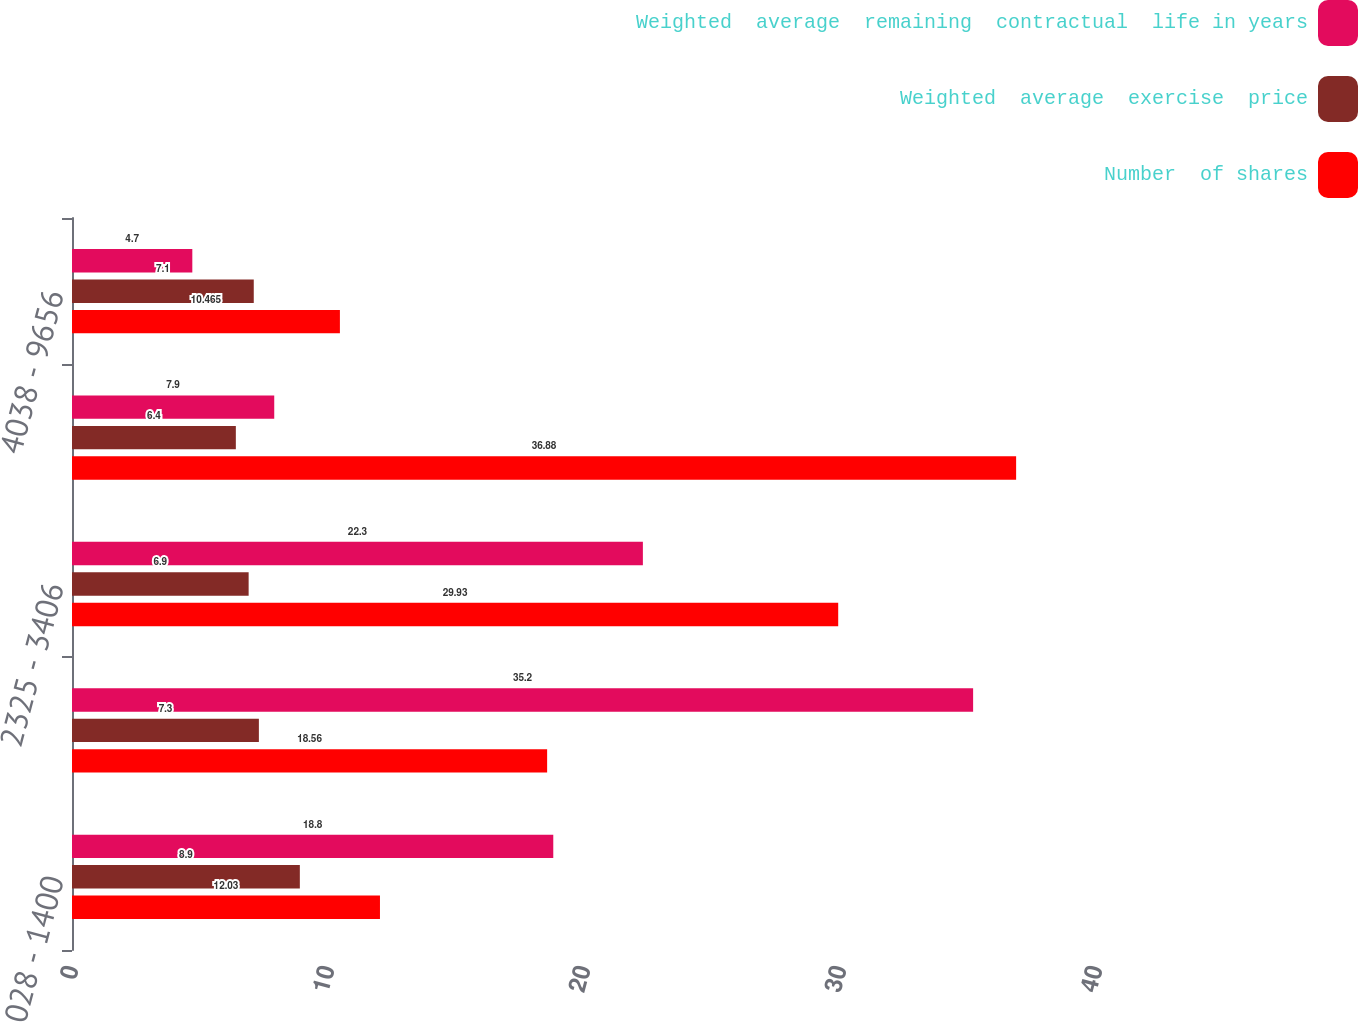Convert chart. <chart><loc_0><loc_0><loc_500><loc_500><stacked_bar_chart><ecel><fcel>028 - 1400<fcel>1402 - 2283<fcel>2325 - 3406<fcel>3409 - 4006<fcel>4038 - 9656<nl><fcel>Weighted  average  remaining  contractual  life in years<fcel>18.8<fcel>35.2<fcel>22.3<fcel>7.9<fcel>4.7<nl><fcel>Weighted  average  exercise  price<fcel>8.9<fcel>7.3<fcel>6.9<fcel>6.4<fcel>7.1<nl><fcel>Number  of shares<fcel>12.03<fcel>18.56<fcel>29.93<fcel>36.88<fcel>10.465<nl></chart> 